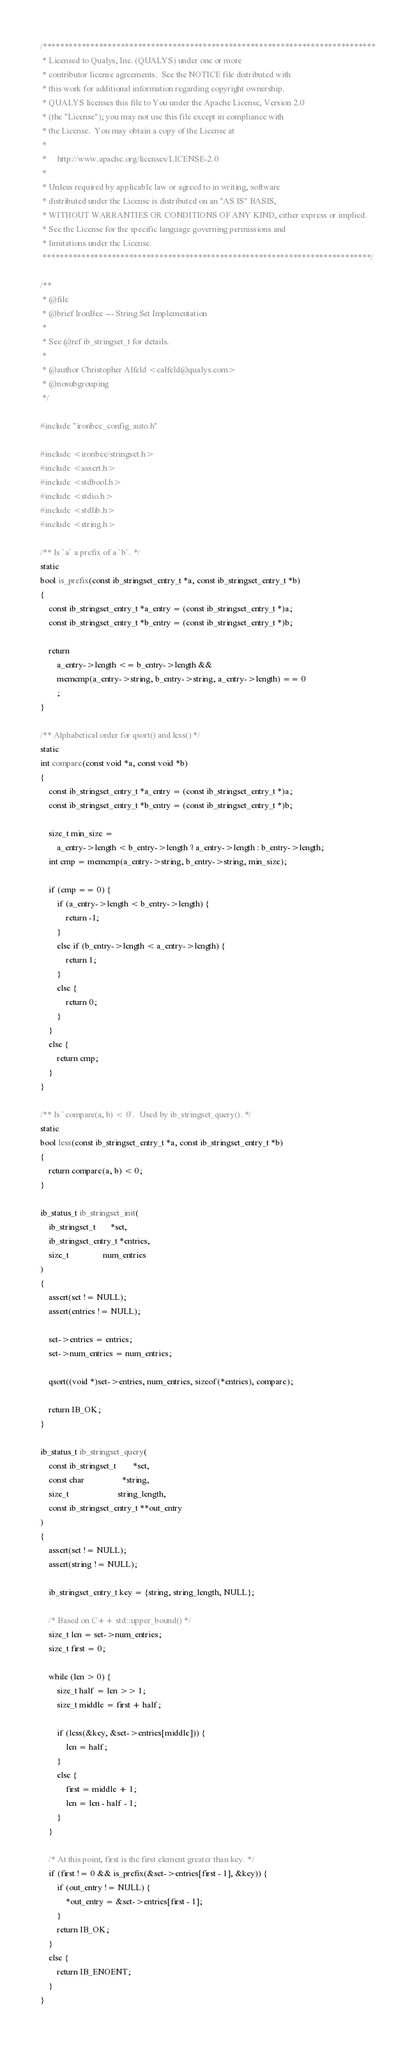<code> <loc_0><loc_0><loc_500><loc_500><_C_>/*****************************************************************************
 * Licensed to Qualys, Inc. (QUALYS) under one or more
 * contributor license agreements.  See the NOTICE file distributed with
 * this work for additional information regarding copyright ownership.
 * QUALYS licenses this file to You under the Apache License, Version 2.0
 * (the "License"); you may not use this file except in compliance with
 * the License.  You may obtain a copy of the License at
 *
 *     http://www.apache.org/licenses/LICENSE-2.0
 *
 * Unless required by applicable law or agreed to in writing, software
 * distributed under the License is distributed on an "AS IS" BASIS,
 * WITHOUT WARRANTIES OR CONDITIONS OF ANY KIND, either express or implied.
 * See the License for the specific language governing permissions and
 * limitations under the License.
 ****************************************************************************/

/**
 * @file
 * @brief IronBee --- String Set Implementation
 *
 * See @ref ib_stringset_t for details.
 *
 * @author Christopher Alfeld <calfeld@qualys.com>
 * @nosubgrouping
 */

#include "ironbee_config_auto.h"

#include <ironbee/stringset.h>
#include <assert.h>
#include <stdbool.h>
#include <stdio.h>
#include <stdlib.h>
#include <string.h>

/** Is `a` a prefix of a `b`. */
static
bool is_prefix(const ib_stringset_entry_t *a, const ib_stringset_entry_t *b)
{
    const ib_stringset_entry_t *a_entry = (const ib_stringset_entry_t *)a;
    const ib_stringset_entry_t *b_entry = (const ib_stringset_entry_t *)b;

    return
        a_entry->length <= b_entry->length &&
        memcmp(a_entry->string, b_entry->string, a_entry->length) == 0
        ;
}

/** Alphabetical order for qsort() and less() */
static
int compare(const void *a, const void *b)
{
    const ib_stringset_entry_t *a_entry = (const ib_stringset_entry_t *)a;
    const ib_stringset_entry_t *b_entry = (const ib_stringset_entry_t *)b;

    size_t min_size =
        a_entry->length < b_entry->length ? a_entry->length : b_entry->length;
    int cmp = memcmp(a_entry->string, b_entry->string, min_size);

    if (cmp == 0) {
        if (a_entry->length < b_entry->length) {
            return -1;
        }
        else if (b_entry->length < a_entry->length) {
            return 1;
        }
        else {
            return 0;
        }
    }
    else {
        return cmp;
    }
}

/** Is `compare(a, b) < 0`.  Used by ib_stringset_query(). */
static
bool less(const ib_stringset_entry_t *a, const ib_stringset_entry_t *b)
{
    return compare(a, b) < 0;
}

ib_status_t ib_stringset_init(
    ib_stringset_t       *set,
    ib_stringset_entry_t *entries,
    size_t                num_entries
)
{
    assert(set != NULL);
    assert(entries != NULL);

    set->entries = entries;
    set->num_entries = num_entries;

    qsort((void *)set->entries, num_entries, sizeof(*entries), compare);

    return IB_OK;
}

ib_status_t ib_stringset_query(
    const ib_stringset_t        *set,
    const char                  *string,
    size_t                       string_length,
    const ib_stringset_entry_t **out_entry
)
{
    assert(set != NULL);
    assert(string != NULL);

    ib_stringset_entry_t key = {string, string_length, NULL};

    /* Based on C++ std::upper_bound() */
    size_t len = set->num_entries;
    size_t first = 0;

    while (len > 0) {
        size_t half = len >> 1;
        size_t middle = first + half;

        if (less(&key, &set->entries[middle])) {
            len = half;
        }
        else {
            first = middle + 1;
            len = len - half - 1;
        }
    }

    /* At this point, first is the first element greater than key. */
    if (first != 0 && is_prefix(&set->entries[first - 1], &key)) {
        if (out_entry != NULL) {
            *out_entry = &set->entries[first - 1];
        }
        return IB_OK;
    }
    else {
        return IB_ENOENT;
    }
}
</code> 